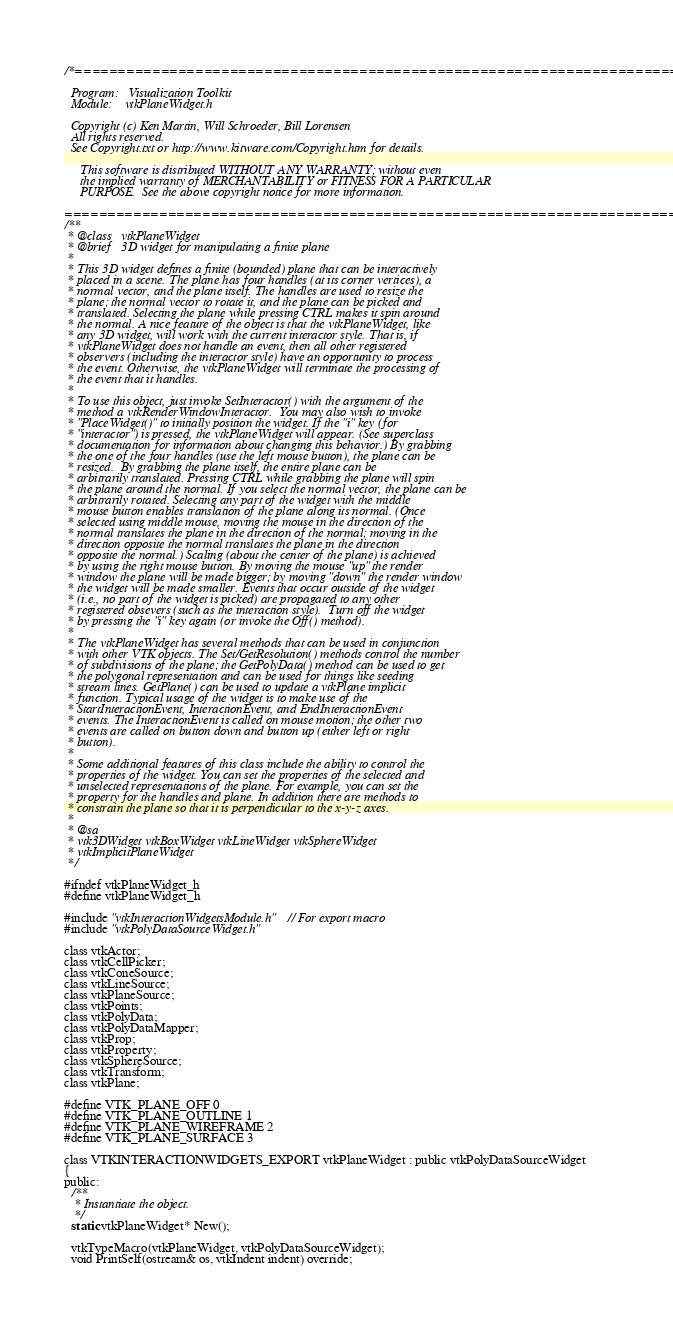Convert code to text. <code><loc_0><loc_0><loc_500><loc_500><_C_>/*=========================================================================

  Program:   Visualization Toolkit
  Module:    vtkPlaneWidget.h

  Copyright (c) Ken Martin, Will Schroeder, Bill Lorensen
  All rights reserved.
  See Copyright.txt or http://www.kitware.com/Copyright.htm for details.

     This software is distributed WITHOUT ANY WARRANTY; without even
     the implied warranty of MERCHANTABILITY or FITNESS FOR A PARTICULAR
     PURPOSE.  See the above copyright notice for more information.

=========================================================================*/
/**
 * @class   vtkPlaneWidget
 * @brief   3D widget for manipulating a finite plane
 *
 * This 3D widget defines a finite (bounded) plane that can be interactively
 * placed in a scene. The plane has four handles (at its corner vertices), a
 * normal vector, and the plane itself. The handles are used to resize the
 * plane; the normal vector to rotate it, and the plane can be picked and
 * translated. Selecting the plane while pressing CTRL makes it spin around
 * the normal. A nice feature of the object is that the vtkPlaneWidget, like
 * any 3D widget, will work with the current interactor style. That is, if
 * vtkPlaneWidget does not handle an event, then all other registered
 * observers (including the interactor style) have an opportunity to process
 * the event. Otherwise, the vtkPlaneWidget will terminate the processing of
 * the event that it handles.
 *
 * To use this object, just invoke SetInteractor() with the argument of the
 * method a vtkRenderWindowInteractor.  You may also wish to invoke
 * "PlaceWidget()" to initially position the widget. If the "i" key (for
 * "interactor") is pressed, the vtkPlaneWidget will appear. (See superclass
 * documentation for information about changing this behavior.) By grabbing
 * the one of the four handles (use the left mouse button), the plane can be
 * resized.  By grabbing the plane itself, the entire plane can be
 * arbitrarily translated. Pressing CTRL while grabbing the plane will spin
 * the plane around the normal. If you select the normal vector, the plane can be
 * arbitrarily rotated. Selecting any part of the widget with the middle
 * mouse button enables translation of the plane along its normal. (Once
 * selected using middle mouse, moving the mouse in the direction of the
 * normal translates the plane in the direction of the normal; moving in the
 * direction opposite the normal translates the plane in the direction
 * opposite the normal.) Scaling (about the center of the plane) is achieved
 * by using the right mouse button. By moving the mouse "up" the render
 * window the plane will be made bigger; by moving "down" the render window
 * the widget will be made smaller. Events that occur outside of the widget
 * (i.e., no part of the widget is picked) are propagated to any other
 * registered obsevers (such as the interaction style).  Turn off the widget
 * by pressing the "i" key again (or invoke the Off() method).
 *
 * The vtkPlaneWidget has several methods that can be used in conjunction
 * with other VTK objects. The Set/GetResolution() methods control the number
 * of subdivisions of the plane; the GetPolyData() method can be used to get
 * the polygonal representation and can be used for things like seeding
 * stream lines. GetPlane() can be used to update a vtkPlane implicit
 * function. Typical usage of the widget is to make use of the
 * StartInteractionEvent, InteractionEvent, and EndInteractionEvent
 * events. The InteractionEvent is called on mouse motion; the other two
 * events are called on button down and button up (either left or right
 * button).
 *
 * Some additional features of this class include the ability to control the
 * properties of the widget. You can set the properties of the selected and
 * unselected representations of the plane. For example, you can set the
 * property for the handles and plane. In addition there are methods to
 * constrain the plane so that it is perpendicular to the x-y-z axes.
 *
 * @sa
 * vtk3DWidget vtkBoxWidget vtkLineWidget vtkSphereWidget
 * vtkImplicitPlaneWidget
 */

#ifndef vtkPlaneWidget_h
#define vtkPlaneWidget_h

#include "vtkInteractionWidgetsModule.h" // For export macro
#include "vtkPolyDataSourceWidget.h"

class vtkActor;
class vtkCellPicker;
class vtkConeSource;
class vtkLineSource;
class vtkPlaneSource;
class vtkPoints;
class vtkPolyData;
class vtkPolyDataMapper;
class vtkProp;
class vtkProperty;
class vtkSphereSource;
class vtkTransform;
class vtkPlane;

#define VTK_PLANE_OFF 0
#define VTK_PLANE_OUTLINE 1
#define VTK_PLANE_WIREFRAME 2
#define VTK_PLANE_SURFACE 3

class VTKINTERACTIONWIDGETS_EXPORT vtkPlaneWidget : public vtkPolyDataSourceWidget
{
public:
  /**
   * Instantiate the object.
   */
  static vtkPlaneWidget* New();

  vtkTypeMacro(vtkPlaneWidget, vtkPolyDataSourceWidget);
  void PrintSelf(ostream& os, vtkIndent indent) override;
</code> 